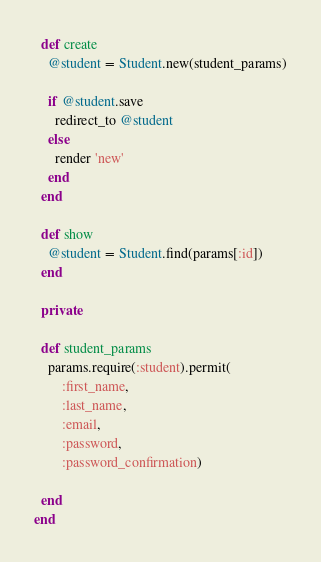<code> <loc_0><loc_0><loc_500><loc_500><_Ruby_>  def create
    @student = Student.new(student_params)

    if @student.save
      redirect_to @student
    else
      render 'new'
    end
  end

  def show
    @student = Student.find(params[:id])
  end

  private

  def student_params
    params.require(:student).permit(
        :first_name,
        :last_name,
        :email,
        :password,
        :password_confirmation)

  end
end</code> 